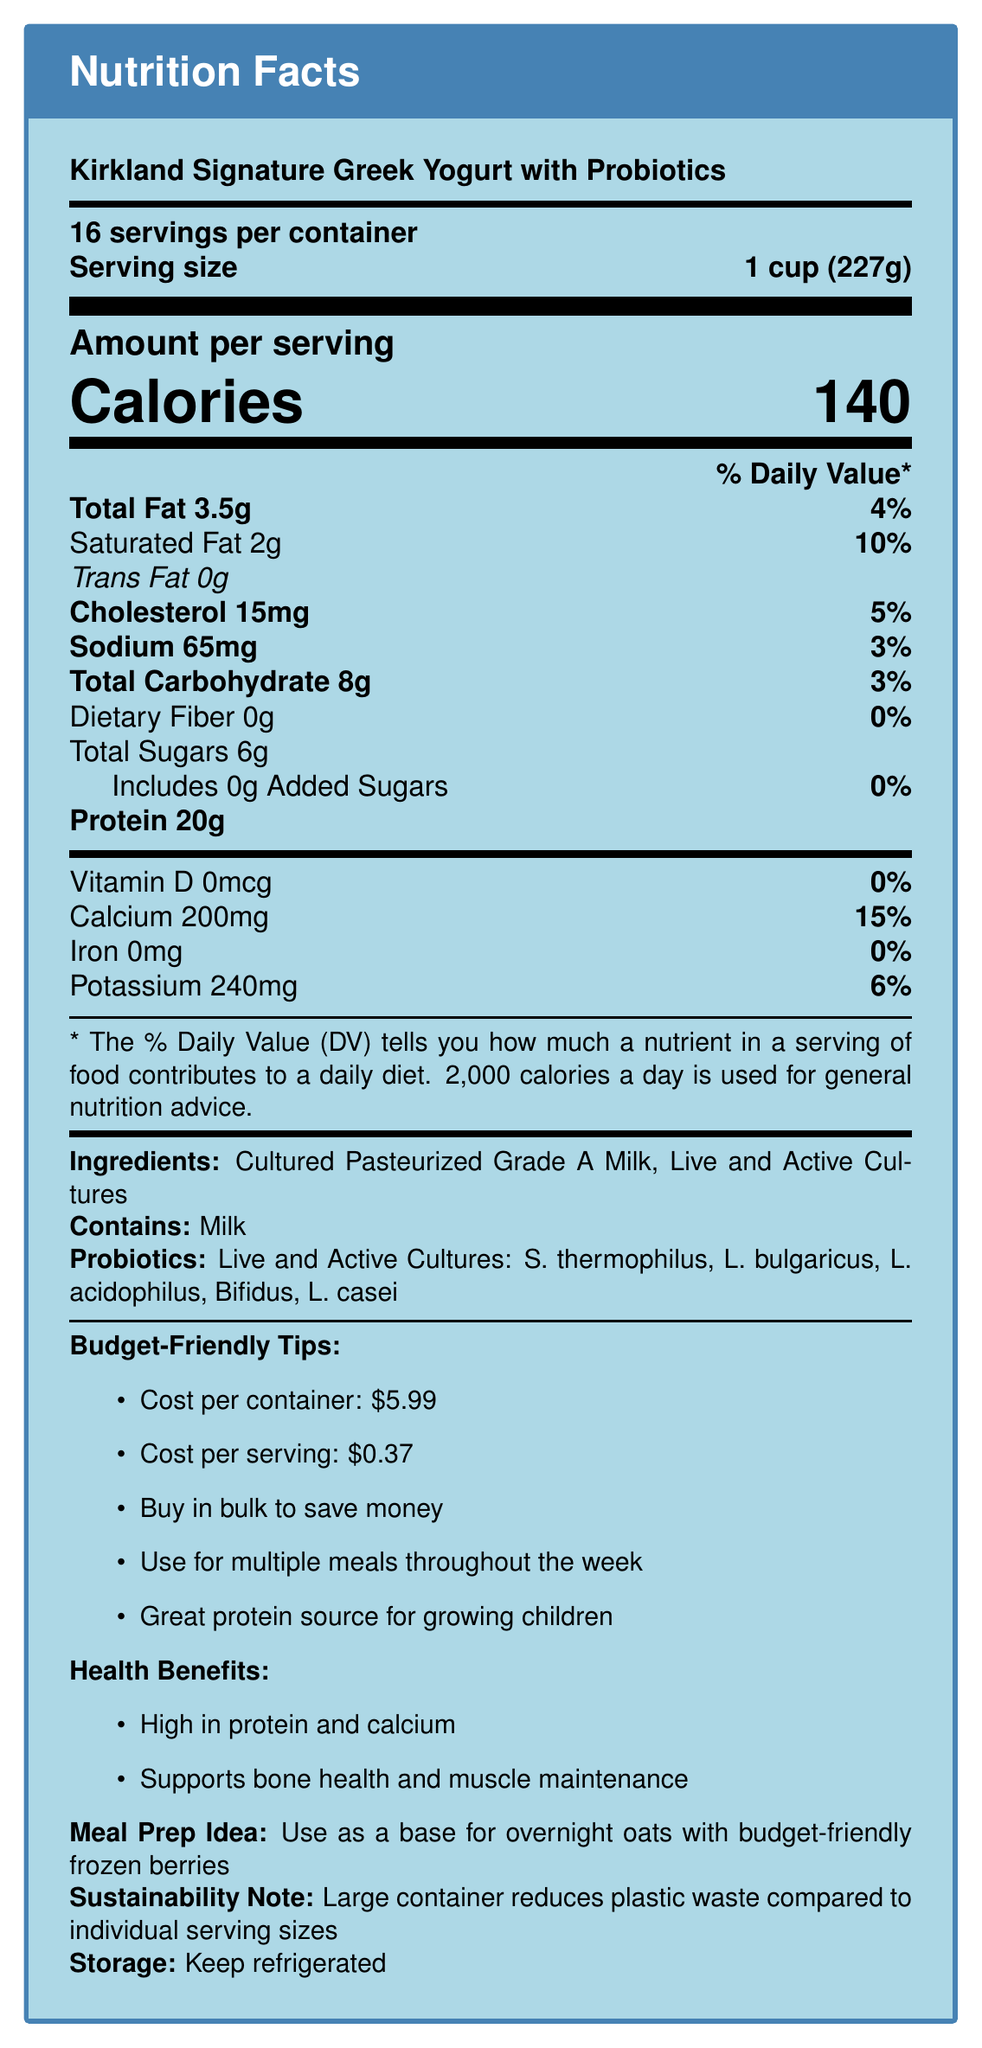what is the serving size? The serving size is clearly mentioned in the document as "1 cup (227g)".
Answer: 1 cup (227g) how many servings are in the container? The document states that there are 16 servings per container.
Answer: 16 servings how many calories are in one serving? The document shows that one serving contains 140 calories.
Answer: 140 calories what is the amount of protein per serving? The document indicates that there is 20g of protein per serving.
Answer: 20g what percentage of daily sodium is in one serving? The document lists that one serving contains 3% of the daily value for sodium.
Answer: 3% what are the ingredients in this yogurt? The ingredients are mentioned towards the end of the document.
Answer: Cultured Pasteurized Grade A Milk, Live and Active Cultures which probiotic cultures are present in the yogurt? The probiotics listed in the document are S. thermophilus, L. bulgaricus, L. acidophilus, Bifidus, and L. casei.
Answer: S. thermophilus, L. bulgaricus, L. acidophilus, Bifidus, L. casei what is the cost per serving? The document specifies that the cost per serving is $0.37.
Answer: $0.37 how much calcium does one serving provide? The document states that one serving provides 200mg of calcium, which is 15% of the daily value.
Answer: 200mg (15% DV) how should the yogurt be stored? The recommended storage instruction in the document is to keep the yogurt refrigerated.
Answer: Keep refrigerated what type of allergen is in the yogurt? The document indicates that the product contains milk as an allergen.
Answer: Milk what is the total carbohydrate content per serving? The document shows that each serving contains 8g of total carbohydrates, which is 3% of the daily value.
Answer: 8g (3% DV) what is the sustainability note mentioned in the document? A. Single-use plastic B. Large container reduces plastic waste C. Recyclable packaging D. No sustainability note provided The document mentions that the large container reduces plastic waste compared to individual serving sizes.
Answer: B which of the following is a budget-friendly tip? A. Use for multiple meals throughout the week B. Avoid buying in bulk C. Only consume on special occasions D. Use as a snack once a month The document suggests using the yogurt for multiple meals throughout the week as a budget-friendly tip.
Answer: A is the yogurt high in saturated fat? According to the document, the yogurt contains 2g of saturated fat, which is 10% of the daily value, and is not considered high.
Answer: No does the document mention the presence of any dietary fiber in the yogurt? The document states that the yogurt has 0g of dietary fiber.
Answer: No summarize the main idea of the document. The document is a comprehensive Nutrition Facts Label and supporting information for Kirkland Signature Greek Yogurt with Probiotics, emphasizing its nutritional content, cost-effectiveness, health benefits, and environmental impact.
Answer: The document provides detailed nutritional information and additional insights about Kirkland Signature Greek Yogurt with Probiotics. It includes serving size, calories, macronutrients, vitamins, and minerals per serving. The document also highlights ingredients, allergen information, probiotic cultures, storage instructions, cost breakdown, budget-friendly tips, health benefits, and sustainability considerations. what is the total cost to buy the yogurt in bulk? The document provides the cost per container and serving but does not mention any bulk purchase prices.
Answer: Not enough information 